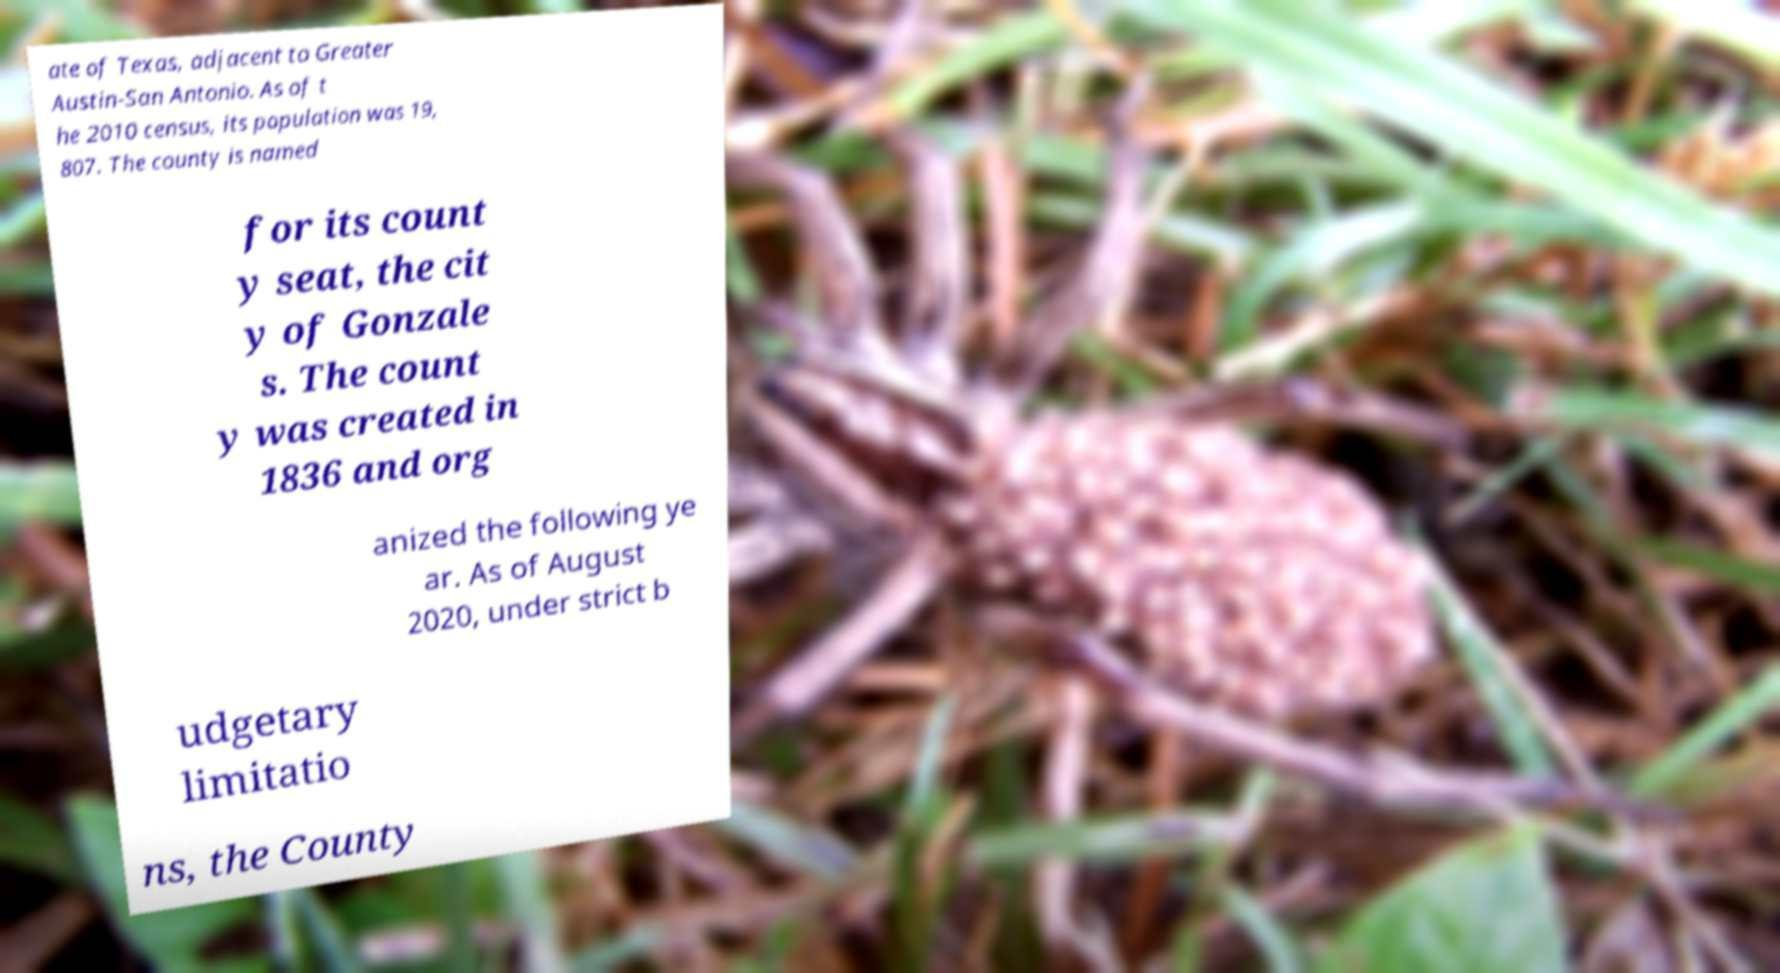Could you assist in decoding the text presented in this image and type it out clearly? ate of Texas, adjacent to Greater Austin-San Antonio. As of t he 2010 census, its population was 19, 807. The county is named for its count y seat, the cit y of Gonzale s. The count y was created in 1836 and org anized the following ye ar. As of August 2020, under strict b udgetary limitatio ns, the County 